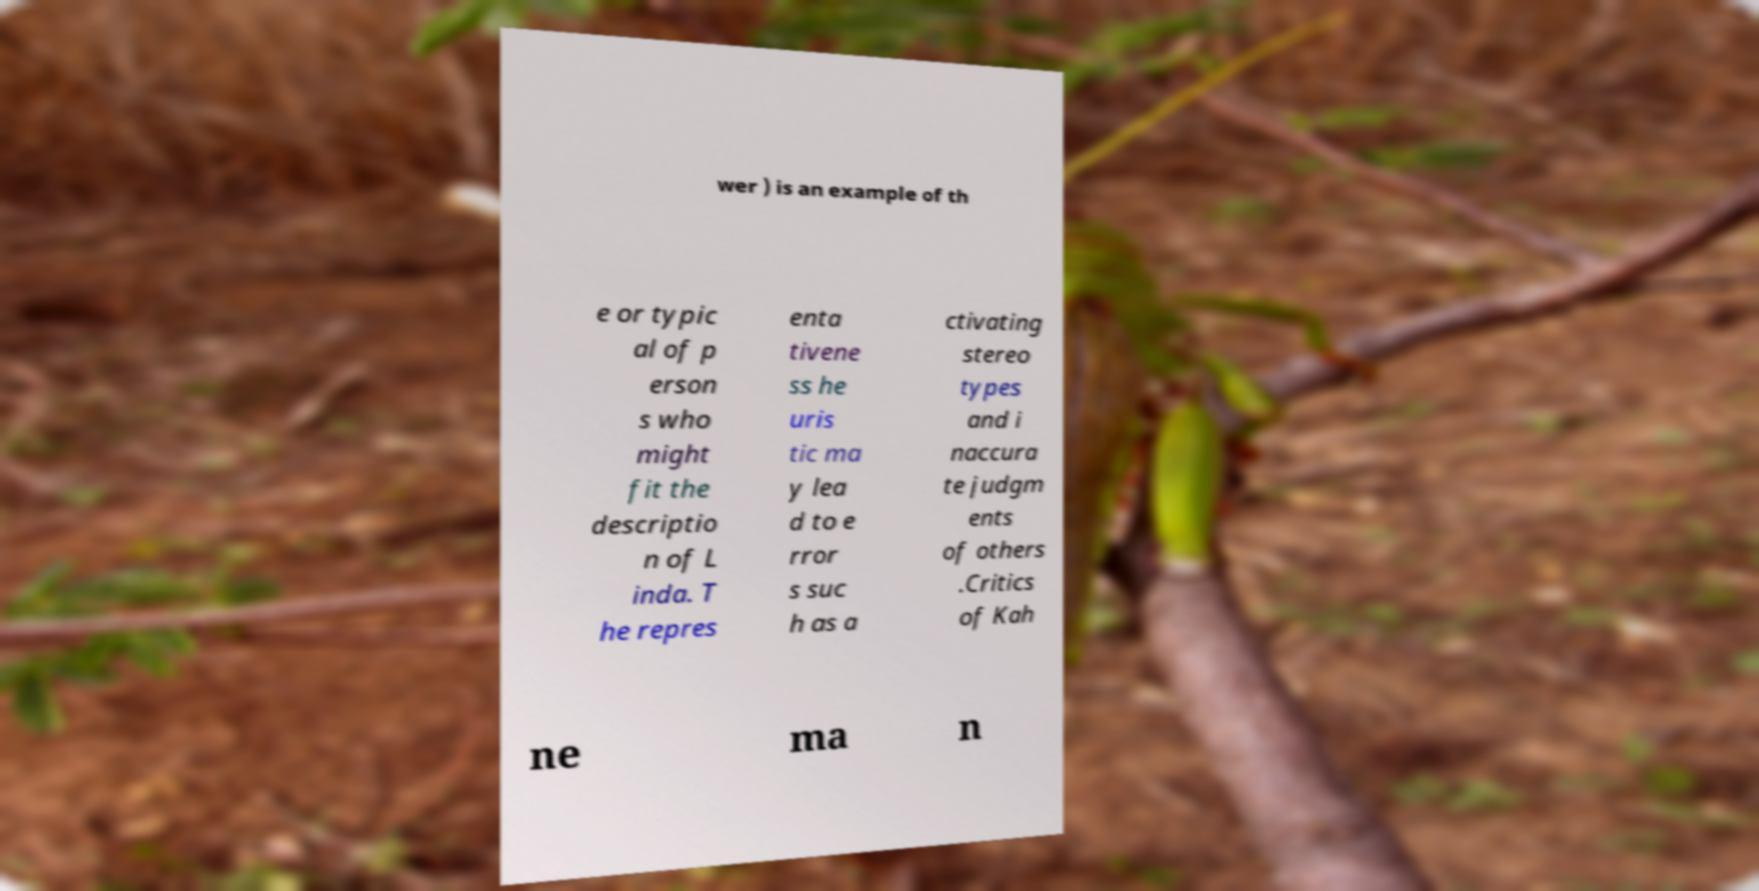Could you extract and type out the text from this image? wer ) is an example of th e or typic al of p erson s who might fit the descriptio n of L inda. T he repres enta tivene ss he uris tic ma y lea d to e rror s suc h as a ctivating stereo types and i naccura te judgm ents of others .Critics of Kah ne ma n 